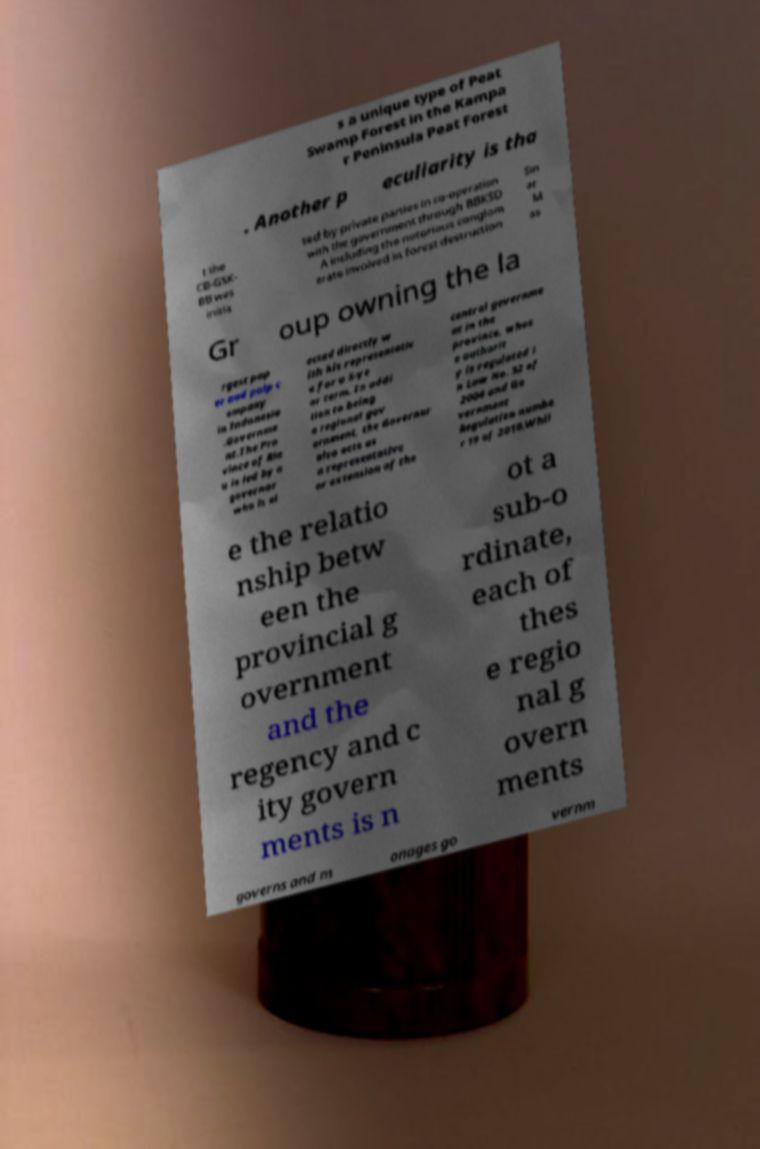There's text embedded in this image that I need extracted. Can you transcribe it verbatim? s a unique type of Peat Swamp Forest in the Kampa r Peninsula Peat Forest . Another p eculiarity is tha t the CB-GSK- BB was initia ted by private parties in co-operation with the government through BBKSD A including the notorious conglom erate involved in forest destruction Sin ar M as Gr oup owning the la rgest pap er and pulp c ompany in Indonesia .Governme nt.The Pro vince of Ria u is led by a governor who is el ected directly w ith his representativ e for a 5-ye ar term. In addi tion to being a regional gov ernment, the Governor also acts as a representative or extension of the central governme nt in the province, whos e authorit y is regulated i n Law No. 32 of 2004 and Go vernment Regulation numbe r 19 of 2010.Whil e the relatio nship betw een the provincial g overnment and the regency and c ity govern ments is n ot a sub-o rdinate, each of thes e regio nal g overn ments governs and m anages go vernm 